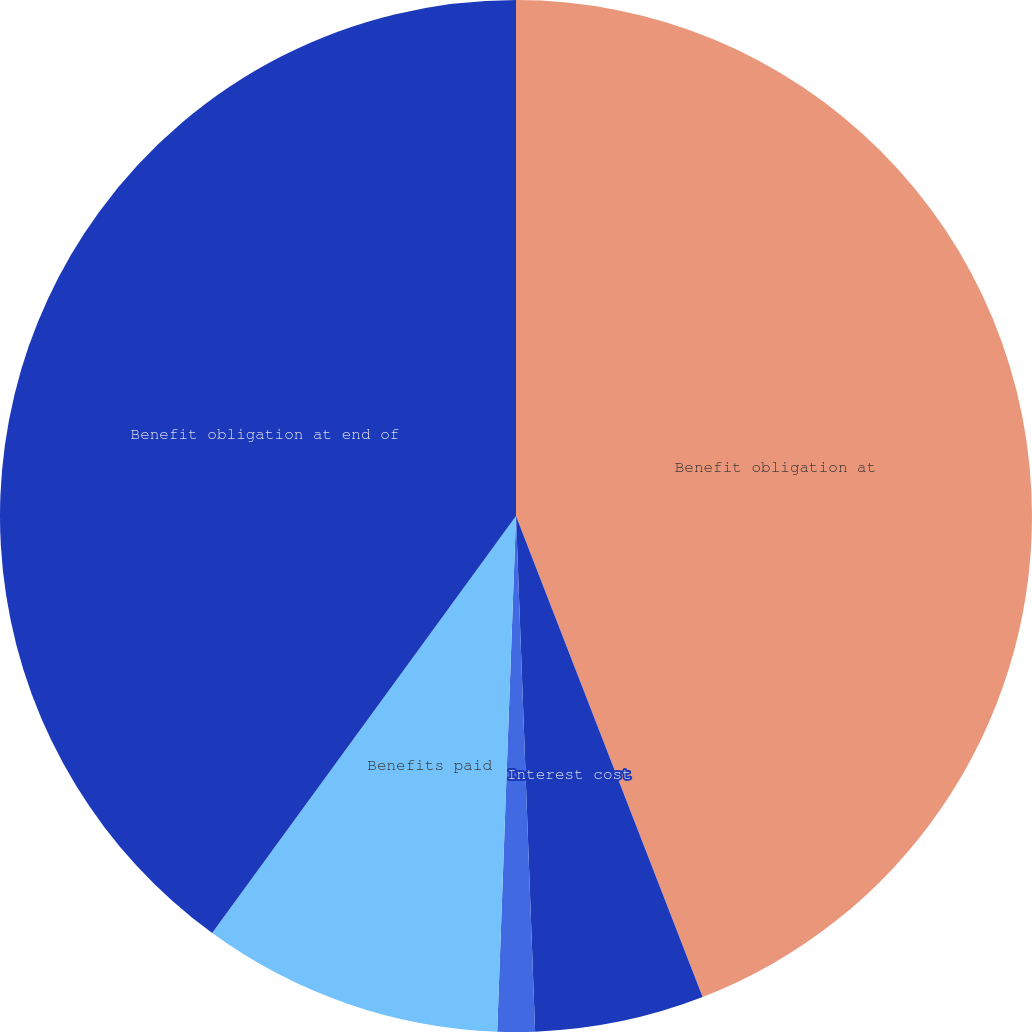<chart> <loc_0><loc_0><loc_500><loc_500><pie_chart><fcel>Benefit obligation at<fcel>Interest cost<fcel>Actuarial loss (gain)<fcel>Benefits paid<fcel>Benefit obligation at end of<nl><fcel>44.11%<fcel>5.3%<fcel>1.17%<fcel>9.44%<fcel>39.98%<nl></chart> 